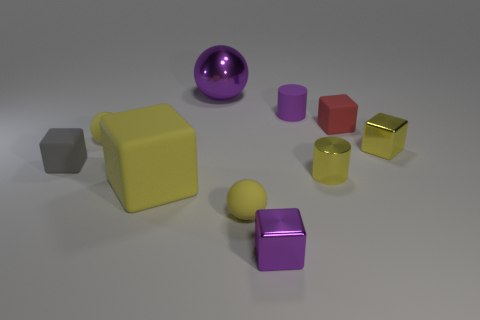Subtract 1 balls. How many balls are left? 2 Subtract all purple blocks. How many blocks are left? 4 Subtract all yellow matte blocks. How many blocks are left? 4 Subtract all brown cubes. Subtract all cyan cylinders. How many cubes are left? 5 Subtract all balls. How many objects are left? 7 Add 5 big spheres. How many big spheres are left? 6 Add 4 big metallic things. How many big metallic things exist? 5 Subtract 0 green balls. How many objects are left? 10 Subtract all purple things. Subtract all large red cubes. How many objects are left? 7 